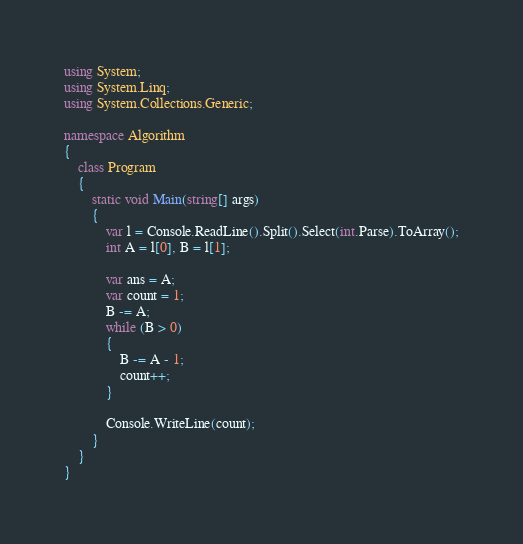<code> <loc_0><loc_0><loc_500><loc_500><_C#_>using System;
using System.Linq;
using System.Collections.Generic;

namespace Algorithm
{
    class Program
    {
        static void Main(string[] args)
        {
            var l = Console.ReadLine().Split().Select(int.Parse).ToArray();
            int A = l[0], B = l[1];

            var ans = A;
            var count = 1;
            B -= A;
            while (B > 0)
            {
                B -= A - 1;
                count++;
            }

            Console.WriteLine(count);
        }
    }
}
</code> 